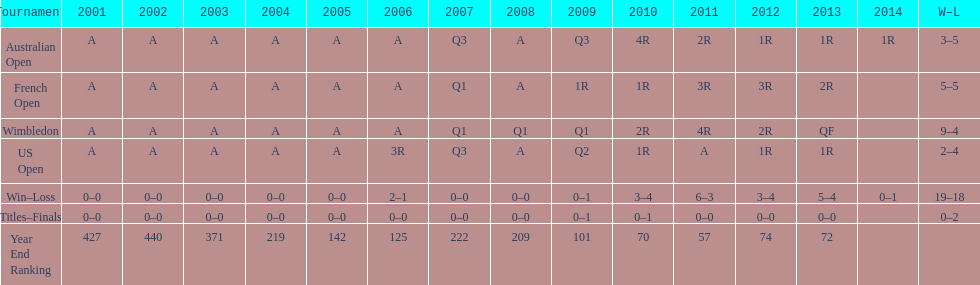Between 2004 and 2011, which year had a higher end ranking? 2011. 